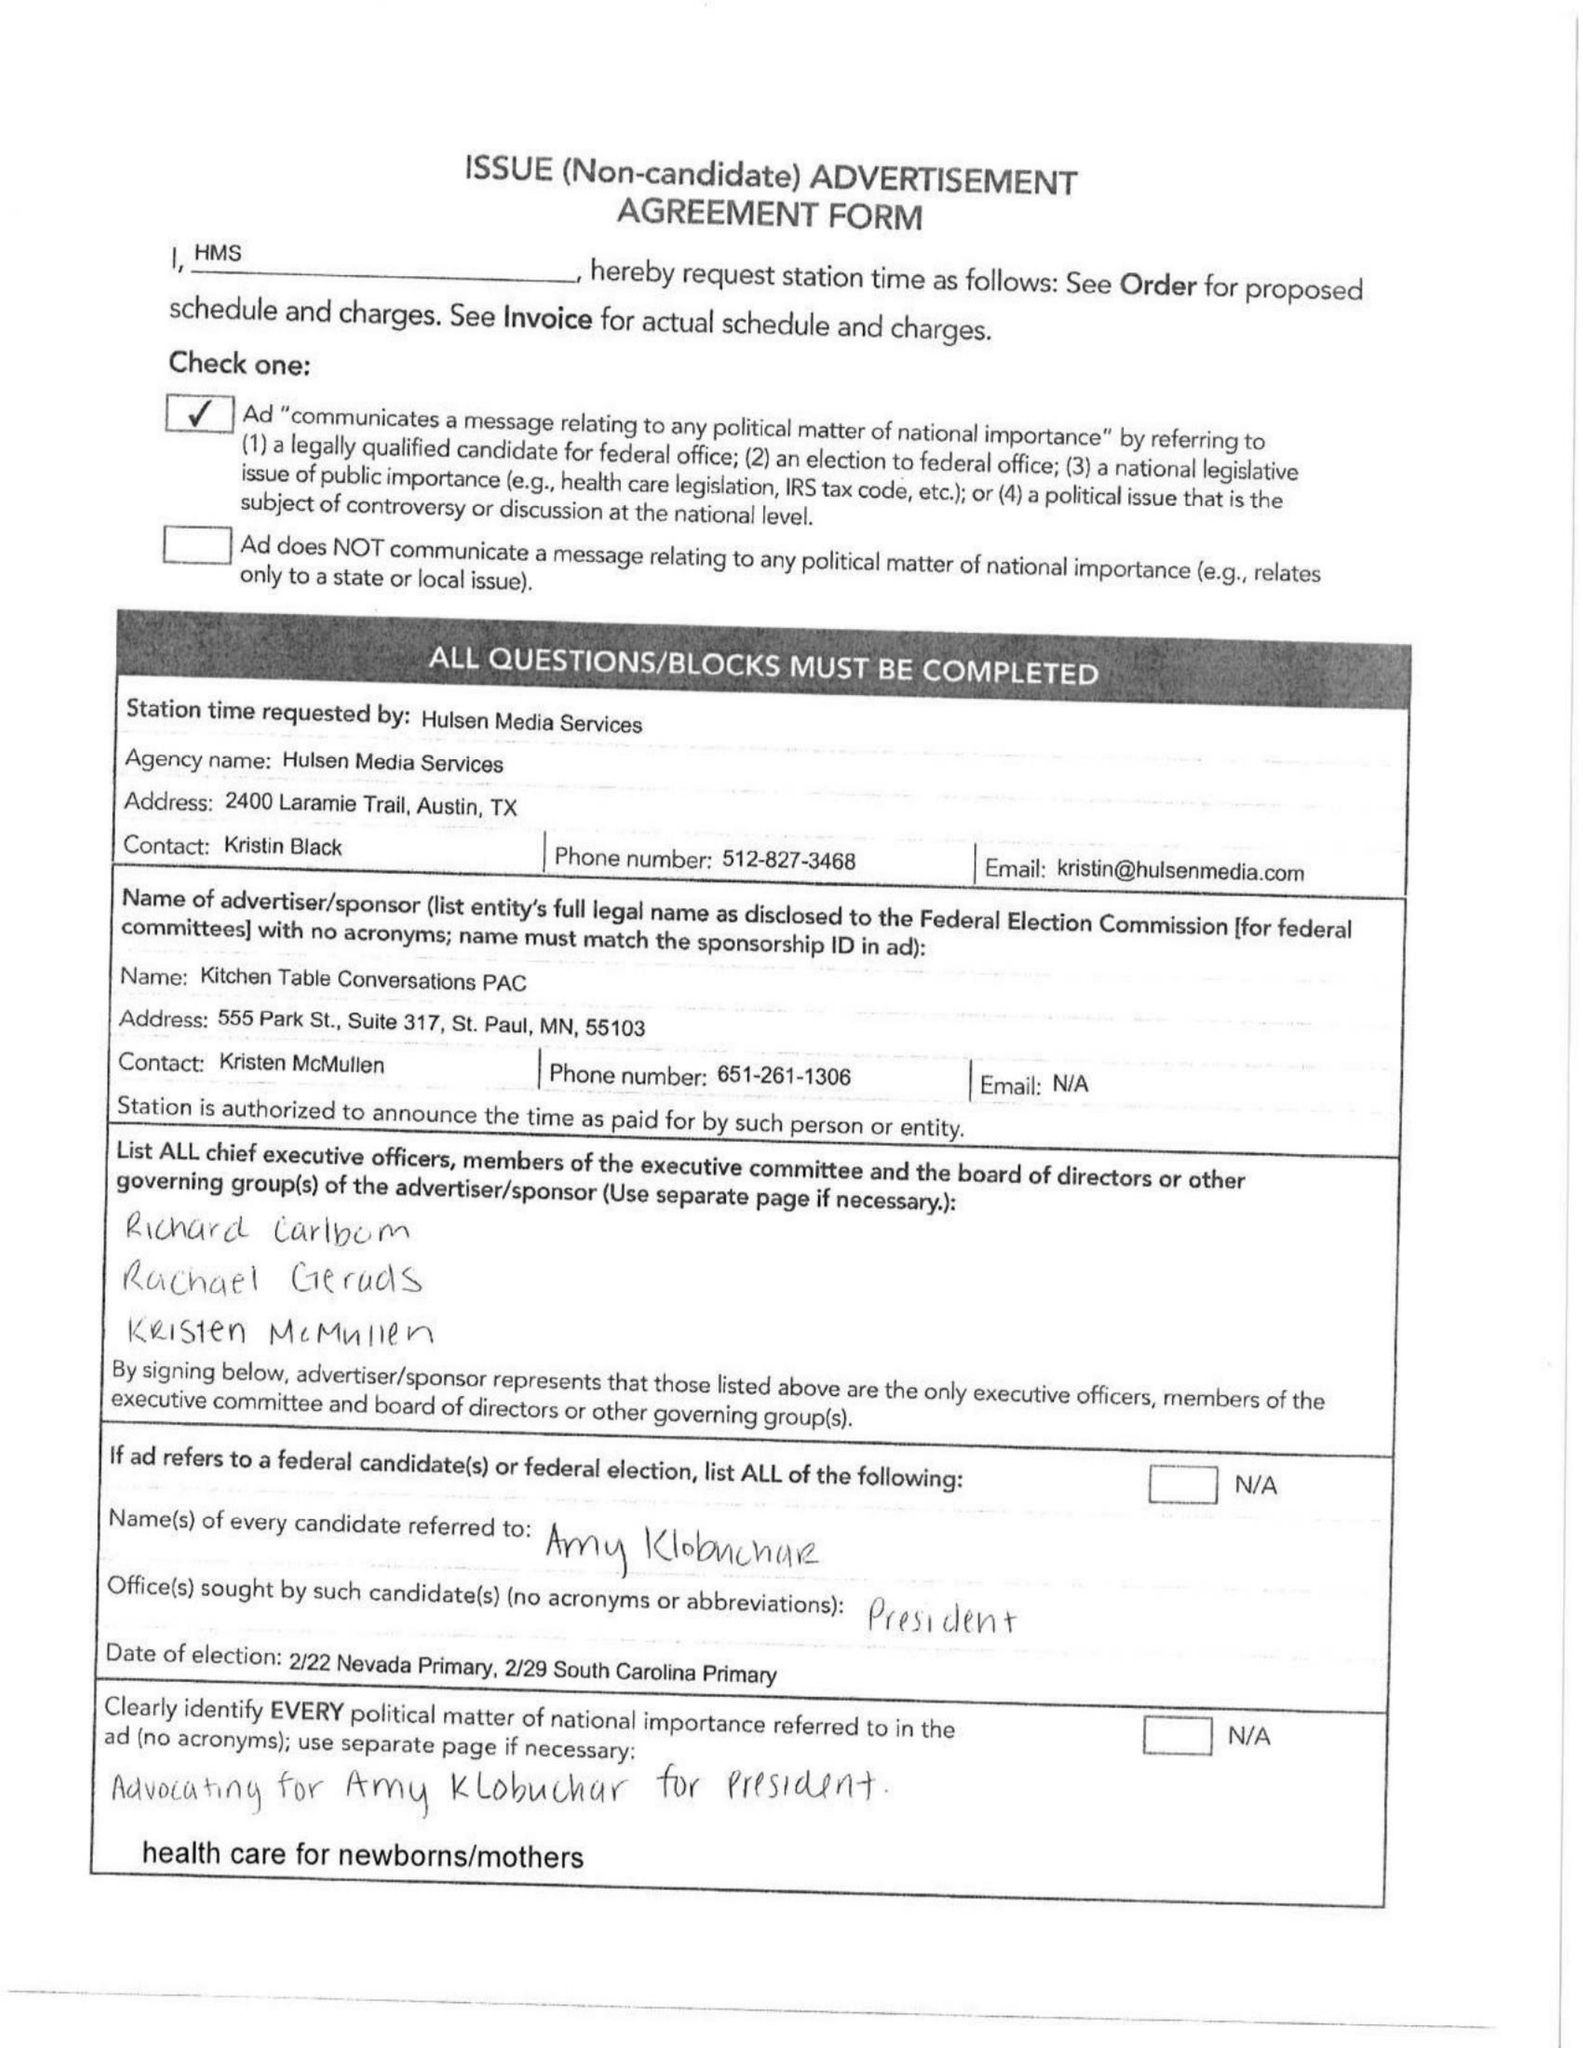What is the value for the flight_from?
Answer the question using a single word or phrase. 02/17/20 